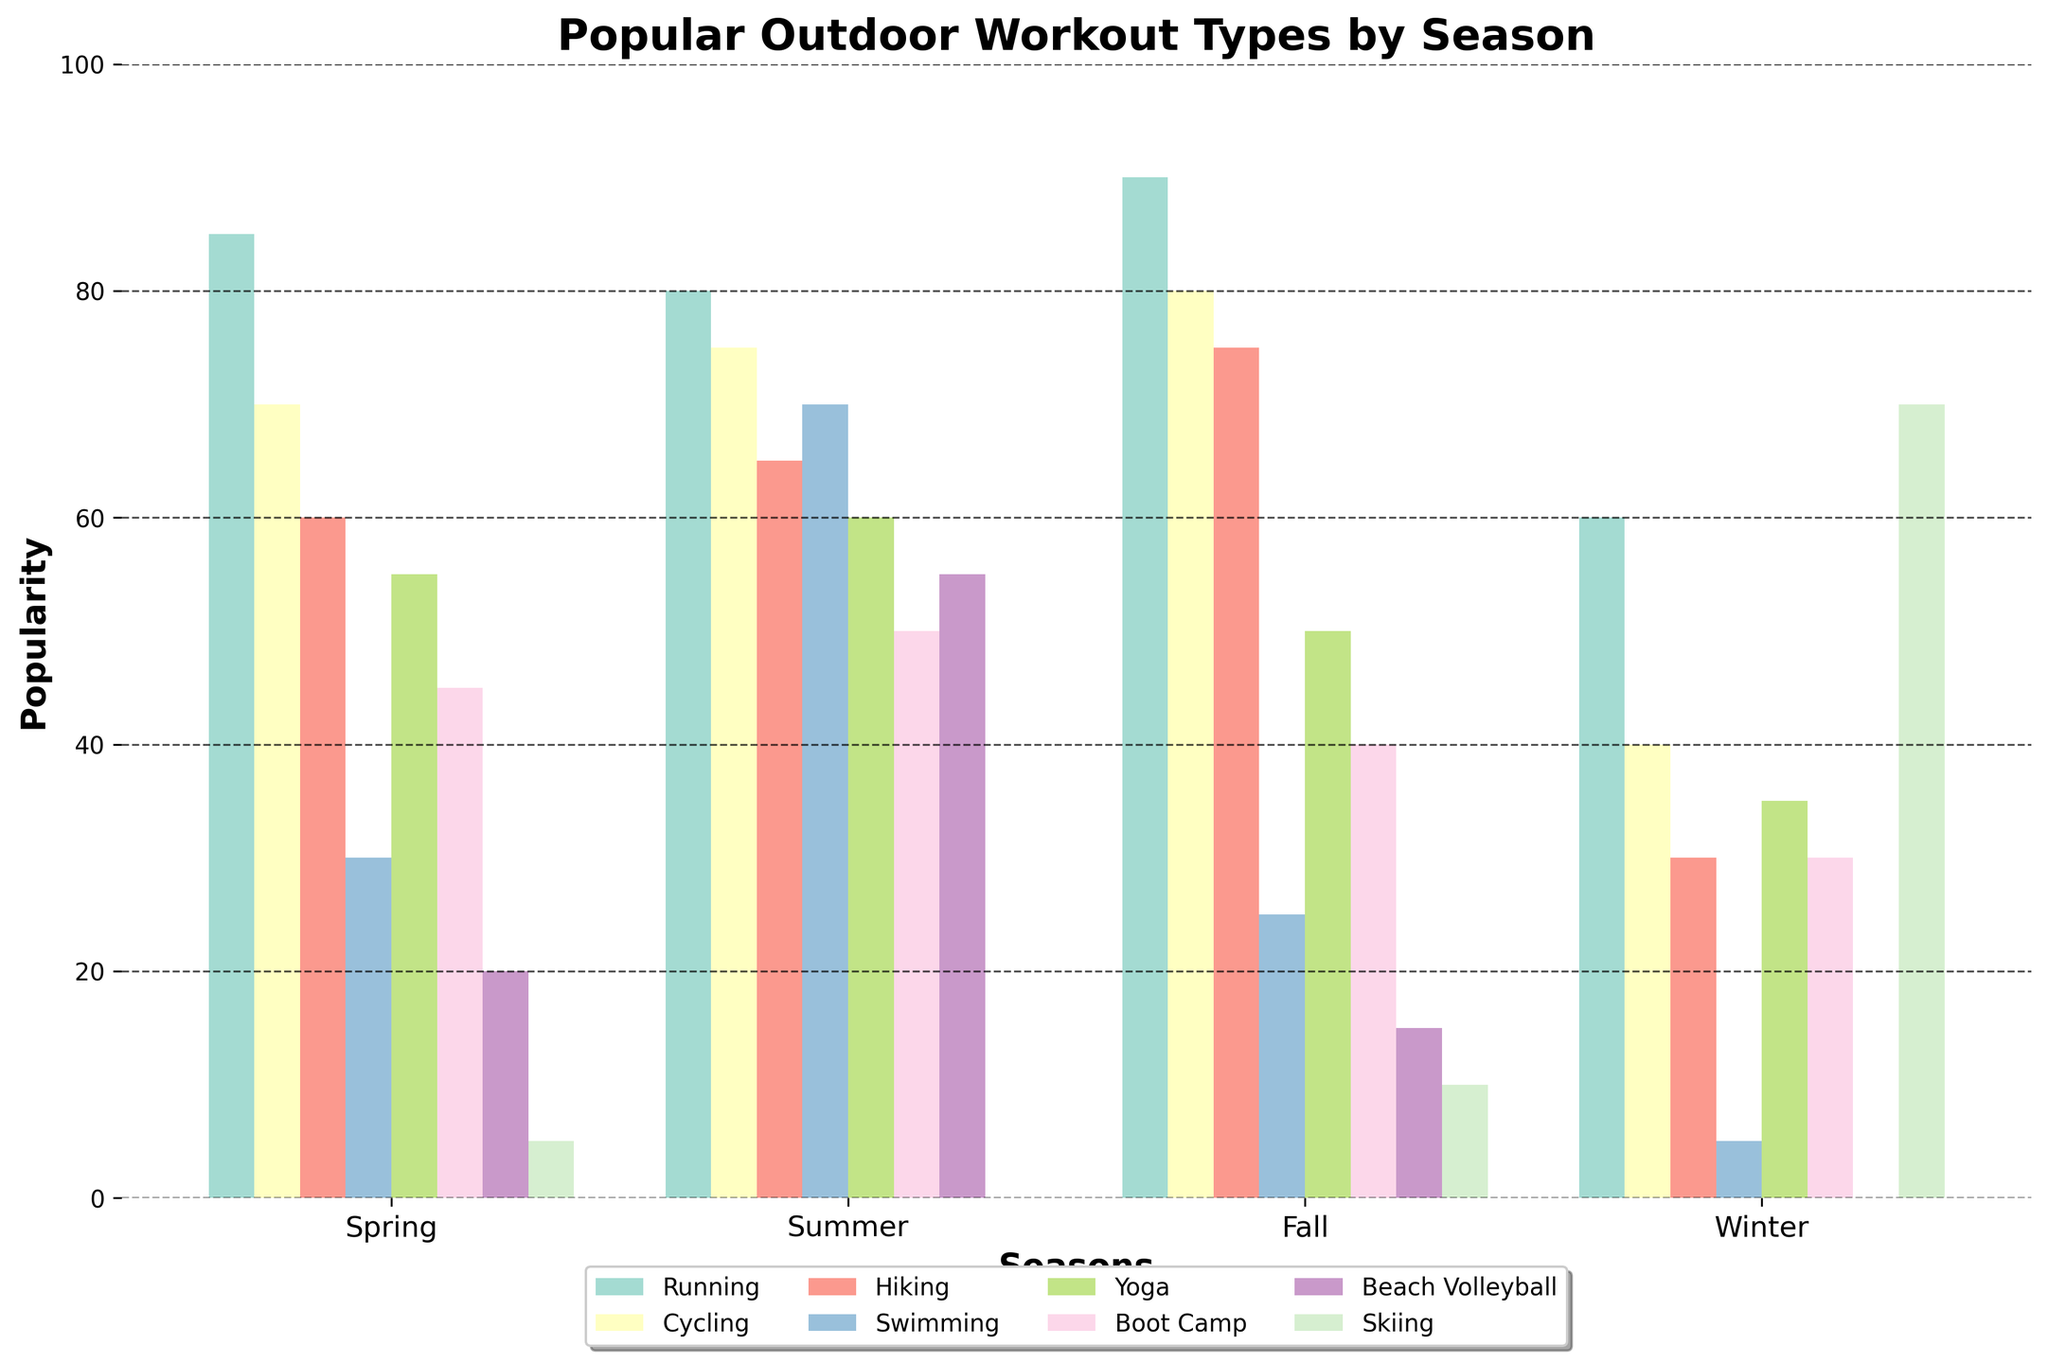What's the most popular workout activity in Summer? To determine the most popular workout activity in Summer, we need to refer to the highest bar in the "Summer" section of the chart. The highest bar in Summer corresponds to Swimming.
Answer: Swimming What is the least popular activity in Winter? To find the least popular activity in Winter, look for the shortest bar in the "Winter" section of the chart. The shortest bar represents Beach Volleyball.
Answer: Beach Volleyball Which season has the highest average popularity for all activities? To find this, we must calculate the average popularity of all activities for each season and compare them. The averages are calculated as follows:  
Spring: (85 + 70 + 60 + 30 + 55 + 45 + 20 + 5) / 8 = 46.25  
Summer: (80 + 75 + 65 + 70 + 60 + 50 + 55 + 0) / 8 = 56.875  
Fall: (90 + 80 + 75 + 25 + 50 + 40 + 15 + 10) / 8 = 48.125  
Winter: (60 + 40 + 30 + 5 + 35 + 30 + 0 + 70) / 8 = 33.75  
Among these, Summer has the highest average popularity.
Answer: Summer Which activity saw the biggest increase from Winter to Spring? To determine the biggest increase, we calculate the difference in popularity for each activity from Winter to Spring and find the largest positive change:  
Running: 85 - 60 = 25  
Cycling: 70 - 40 = 30  
Hiking: 60 - 30 = 30  
Swimming: 30 - 5 = 25  
Yoga: 55 - 35 = 20  
Boot Camp: 45 - 30 = 15  
Beach Volleyball: 20 - 0 = 20  
Skiing: 5 - 70 = -65  
Cycling and Hiking both saw the largest increase of 30.
Answer: Cycling, Hiking Which season has the least variability in the popularity of activities? Variability can be analyzed by examining the range or standard deviation of the popularity scores across activities within each season. Calculations for the range (maximum minus minimum) are:  
Spring: 85 - 5 = 80  
Summer: 80 - 0 = 80  
Fall: 90 - 10 = 80  
Winter: 70 - 0 = 70  
Winter has the least variability with a range of 70.
Answer: Winter Is Running more popular in Fall or Spring? Compare the heights of the bars labeled "Running" in Fall and Spring. Running is 90 in Fall and 85 in Spring. Therefore, Running is more popular in Fall.
Answer: Fall How much more popular is Beach Volleyball in Summer compared to Spring? To find this, subtract the popularity of Beach Volleyball in Spring from its popularity in Summer. The values are 55 in Summer and 20 in Spring.  
55 - 20 = 35
Answer: 35 